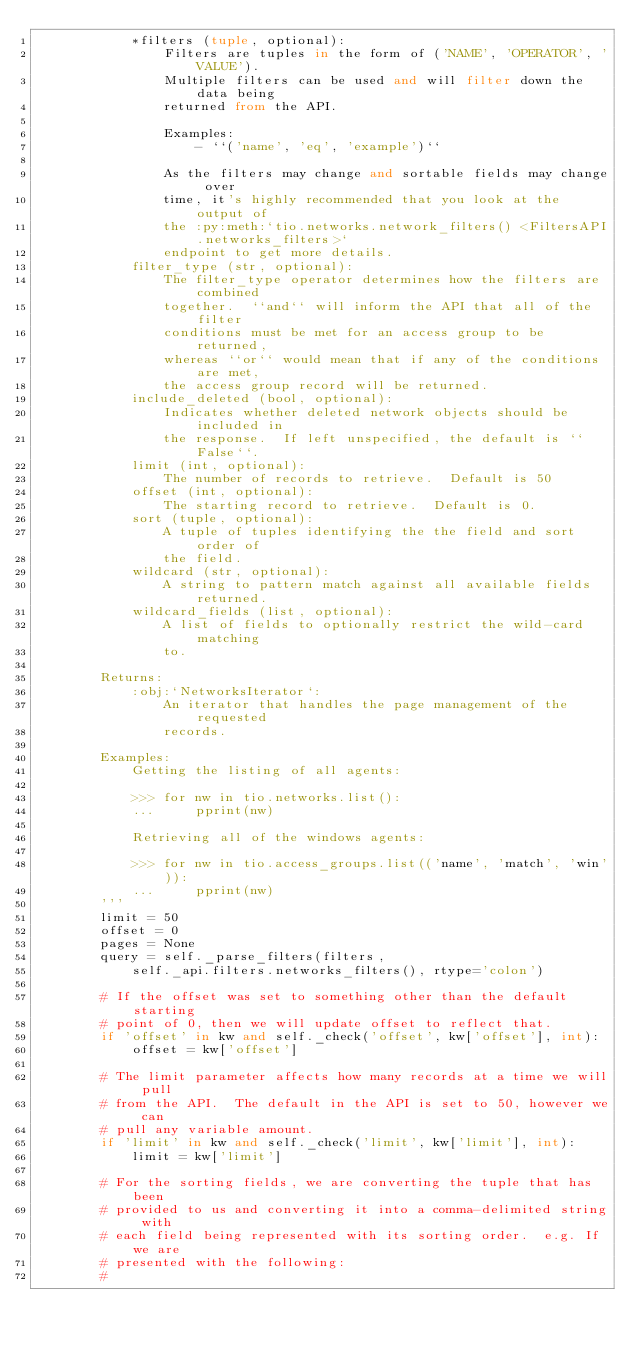Convert code to text. <code><loc_0><loc_0><loc_500><loc_500><_Python_>            *filters (tuple, optional):
                Filters are tuples in the form of ('NAME', 'OPERATOR', 'VALUE').
                Multiple filters can be used and will filter down the data being
                returned from the API.

                Examples:
                    - ``('name', 'eq', 'example')``

                As the filters may change and sortable fields may change over
                time, it's highly recommended that you look at the output of
                the :py:meth:`tio.networks.network_filters() <FiltersAPI.networks_filters>`
                endpoint to get more details.
            filter_type (str, optional):
                The filter_type operator determines how the filters are combined
                together.  ``and`` will inform the API that all of the filter
                conditions must be met for an access group to be returned,
                whereas ``or`` would mean that if any of the conditions are met,
                the access group record will be returned.
            include_deleted (bool, optional):
                Indicates whether deleted network objects should be included in
                the response.  If left unspecified, the default is ``False``.
            limit (int, optional):
                The number of records to retrieve.  Default is 50
            offset (int, optional):
                The starting record to retrieve.  Default is 0.
            sort (tuple, optional):
                A tuple of tuples identifying the the field and sort order of
                the field.
            wildcard (str, optional):
                A string to pattern match against all available fields returned.
            wildcard_fields (list, optional):
                A list of fields to optionally restrict the wild-card matching
                to.

        Returns:
            :obj:`NetworksIterator`:
                An iterator that handles the page management of the requested
                records.

        Examples:
            Getting the listing of all agents:

            >>> for nw in tio.networks.list():
            ...     pprint(nw)

            Retrieving all of the windows agents:

            >>> for nw in tio.access_groups.list(('name', 'match', 'win')):
            ...     pprint(nw)
        '''
        limit = 50
        offset = 0
        pages = None
        query = self._parse_filters(filters,
            self._api.filters.networks_filters(), rtype='colon')

        # If the offset was set to something other than the default starting
        # point of 0, then we will update offset to reflect that.
        if 'offset' in kw and self._check('offset', kw['offset'], int):
            offset = kw['offset']

        # The limit parameter affects how many records at a time we will pull
        # from the API.  The default in the API is set to 50, however we can
        # pull any variable amount.
        if 'limit' in kw and self._check('limit', kw['limit'], int):
            limit = kw['limit']

        # For the sorting fields, we are converting the tuple that has been
        # provided to us and converting it into a comma-delimited string with
        # each field being represented with its sorting order.  e.g. If we are
        # presented with the following:
        #</code> 